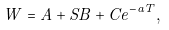Convert formula to latex. <formula><loc_0><loc_0><loc_500><loc_500>W = A + S B + C e ^ { - a T } ,</formula> 